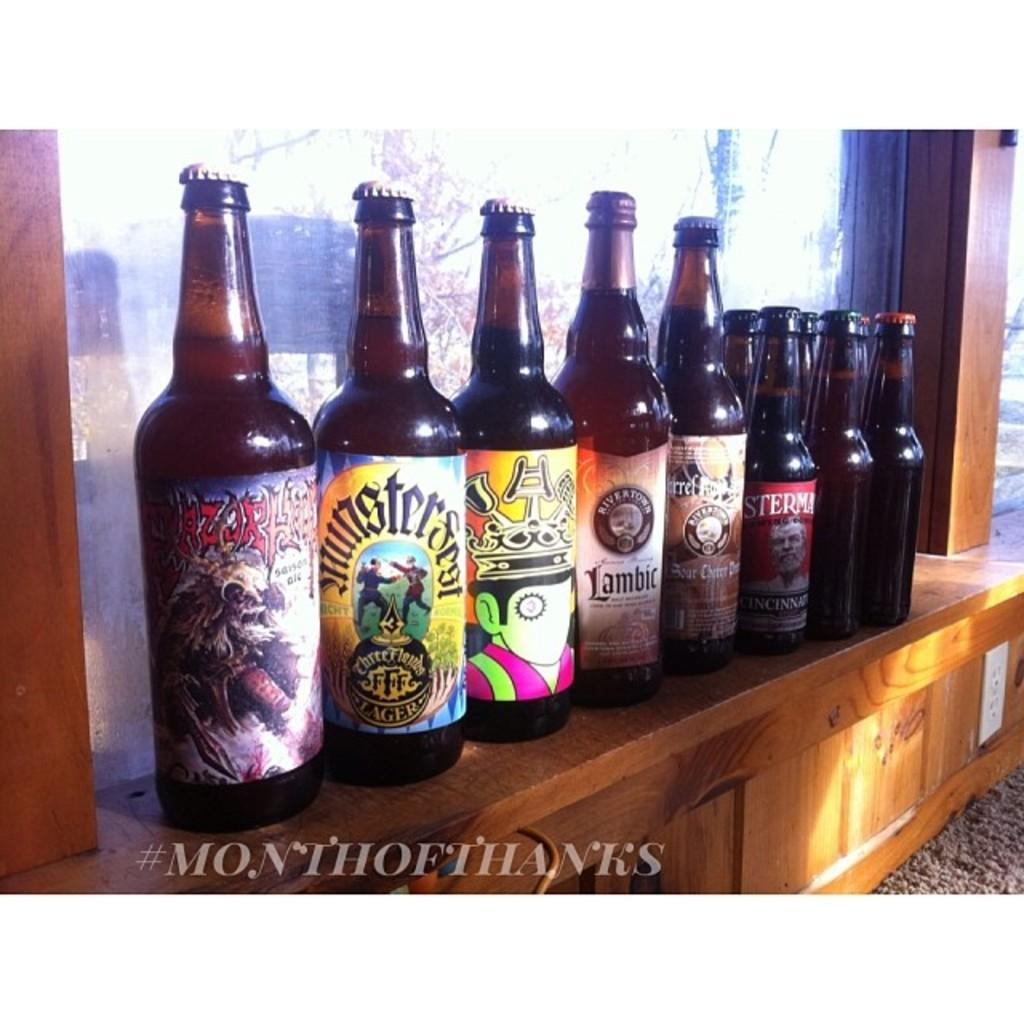<image>
Write a terse but informative summary of the picture. A bottle of Lambic next to several other bottles 